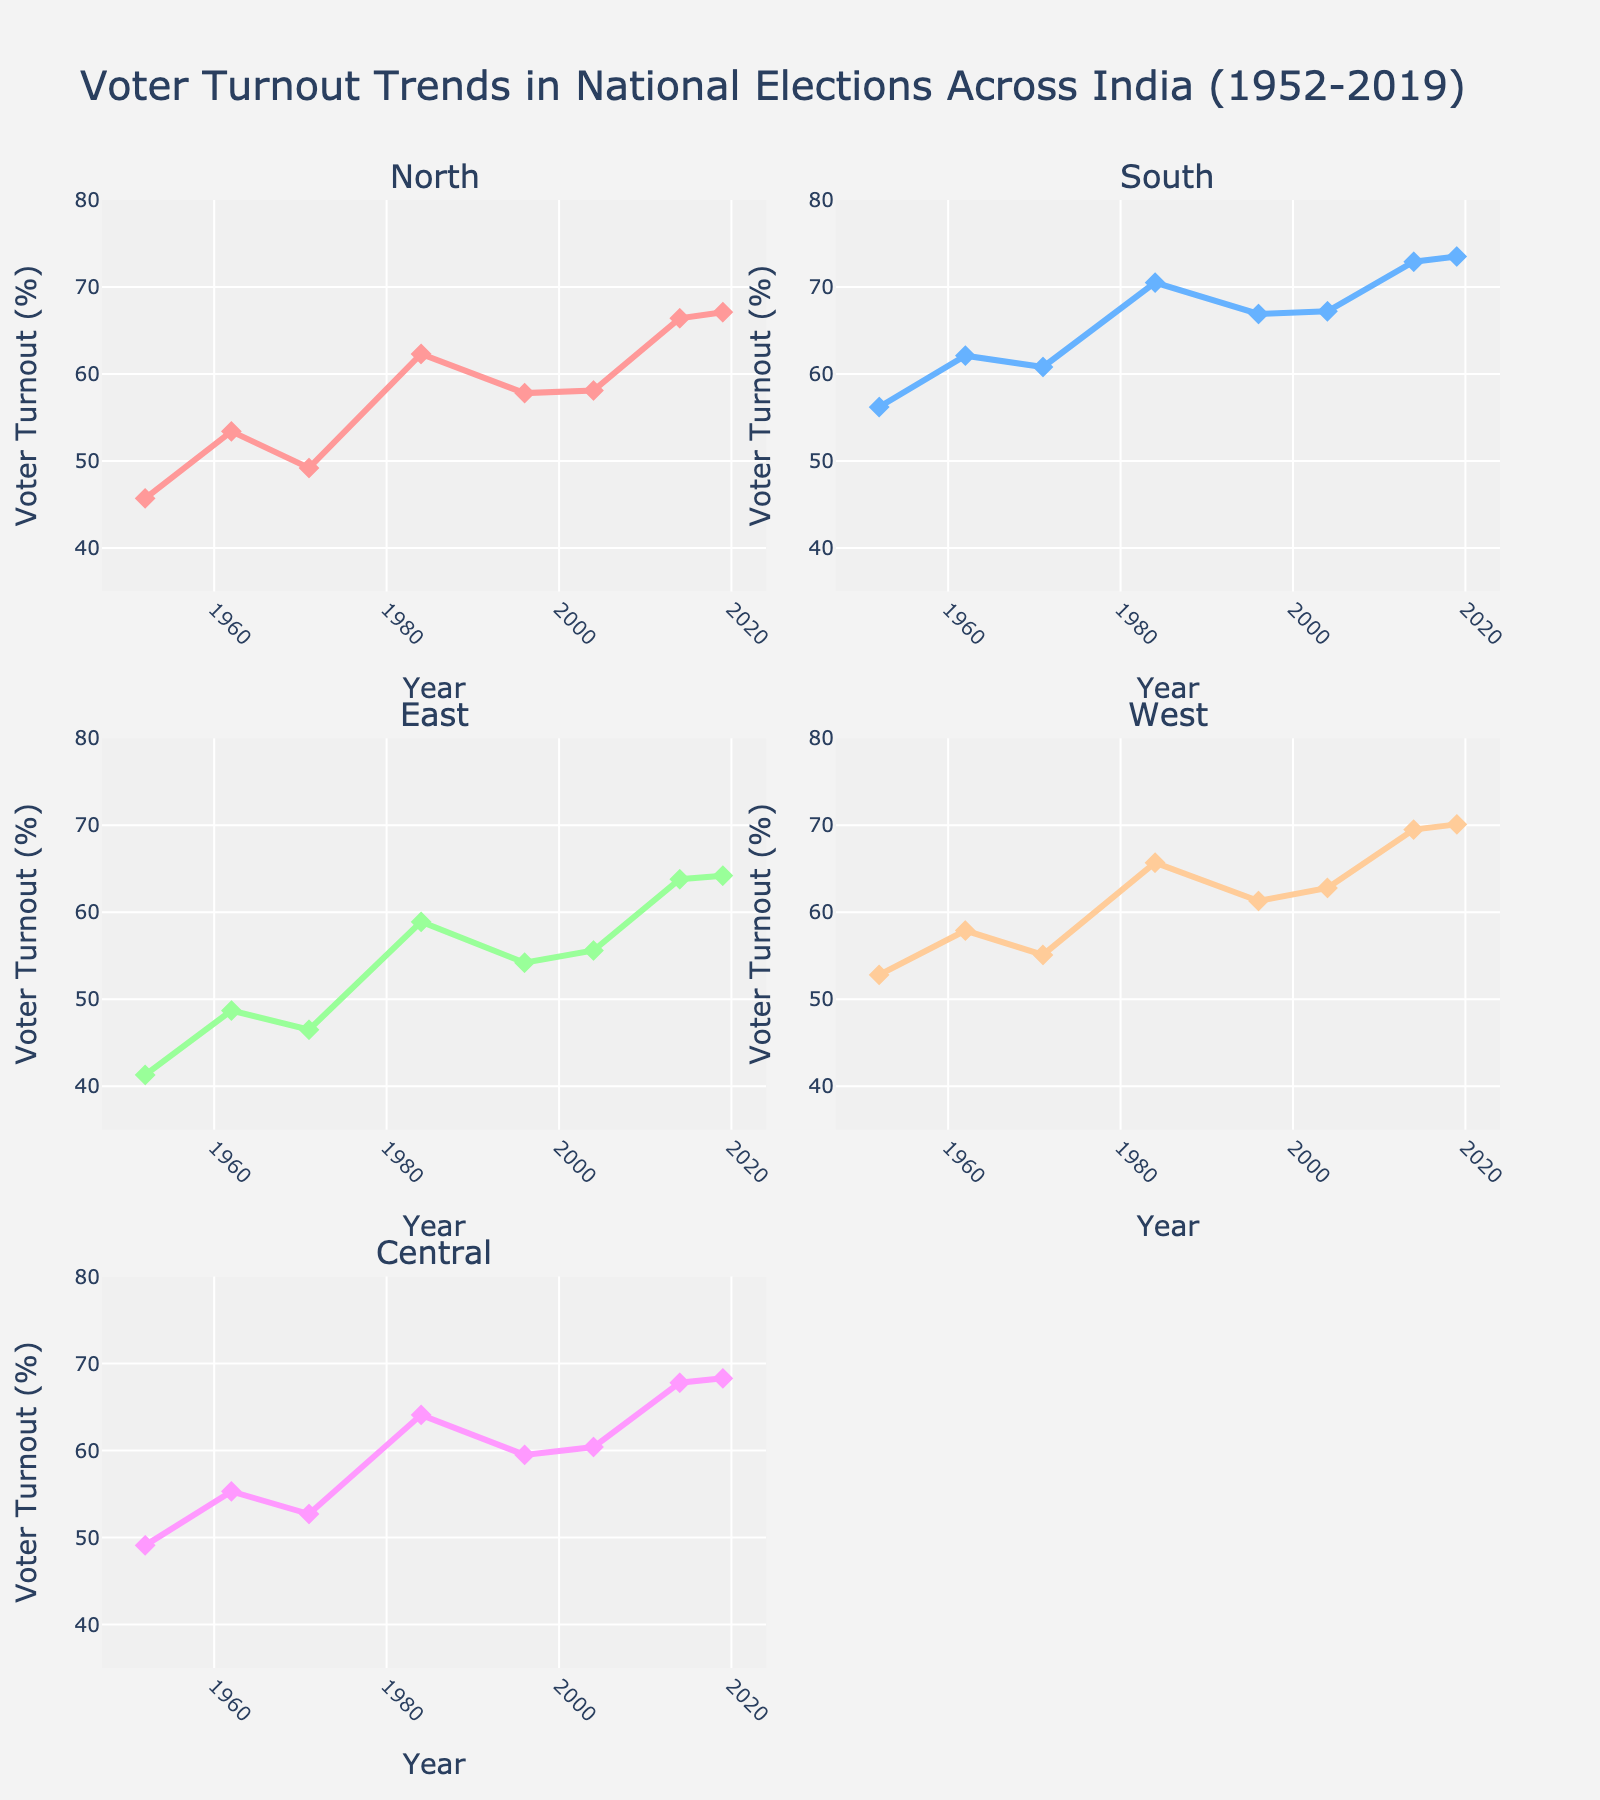what is the title of the figure? The title is prominently displayed at the top center of the figure and reads "Impact of Inflation on Retiree Spending Categories".
Answer: Impact of Inflation on Retiree Spending Categories Which spending category experienced the highest spending change in 2022? By examining the 2022 data points across different subplots, you can see that the Food category has the highest spending change of 8.5%.
Answer: Food How many unique spending categories are shown in the figure? The figure has 5 subplots, each titled with a different spending category: Healthcare, Food, Housing, Transportation, and Recreation.
Answer: 5 What was the inflation rate for transportation in 2021? Looking at the Transportation subplot, the 2021 data point shows an inflation rate of 11.1%.
Answer: 11.1% Which year had a negative spending change for transportation, and what was the inflation rate that year? In the Transportation subplot, the year 2020 shows a negative spending change with an inflation rate of -3.8%.
Answer: 2020, -3.8% Compare the inflation rates of Food and Housing in 2022. Which one is higher and by how much? In 2022, the Food category had an inflation rate of 9.9% while Housing had an inflation rate of 7.1%. To find the difference, subtract 7.1 from 9.9, resulting in a difference of 2.8%.
Answer: Food by 2.8% Calculate the average spending change for Healthcare over the years displayed. The spending changes for Healthcare from 2018 to 2022 are 2.8, 3.5, 2.9, 1.8, and 2.4. Summing these gives 13.4, and dividing by 5 years results in an average of 2.68%.
Answer: 2.68% Which year sees the most dramatic increase in inflation rate for Food compared to the previous year, and what is the increment? Examining the inflation rates for Food, the most dramatic increase is between 2021 (3.9%) and 2022 (9.9%). The increment is 9.9 - 3.9 = 6.0%.
Answer: 2021 to 2022, 6.0% Does Housing ever have a higher inflation rate than Transportation within the years displayed? If so, in which year? Comparing the inflation rates in the Housing and Transportation subplots year by year, Housing has a higher rate than Transportation in the years 2018 (3.2% vs 3.2%) and 2019 (3.3% vs 1.9%).
Answer: 2018, 2019 What pattern, if any, do you notice between inflation rate and spending change in the Recreation category? The Recreation category shows a general pattern where as the inflation rate increases from year to year, the spending change also increases, suggesting a positive correlation.
Answer: Positive correlation 